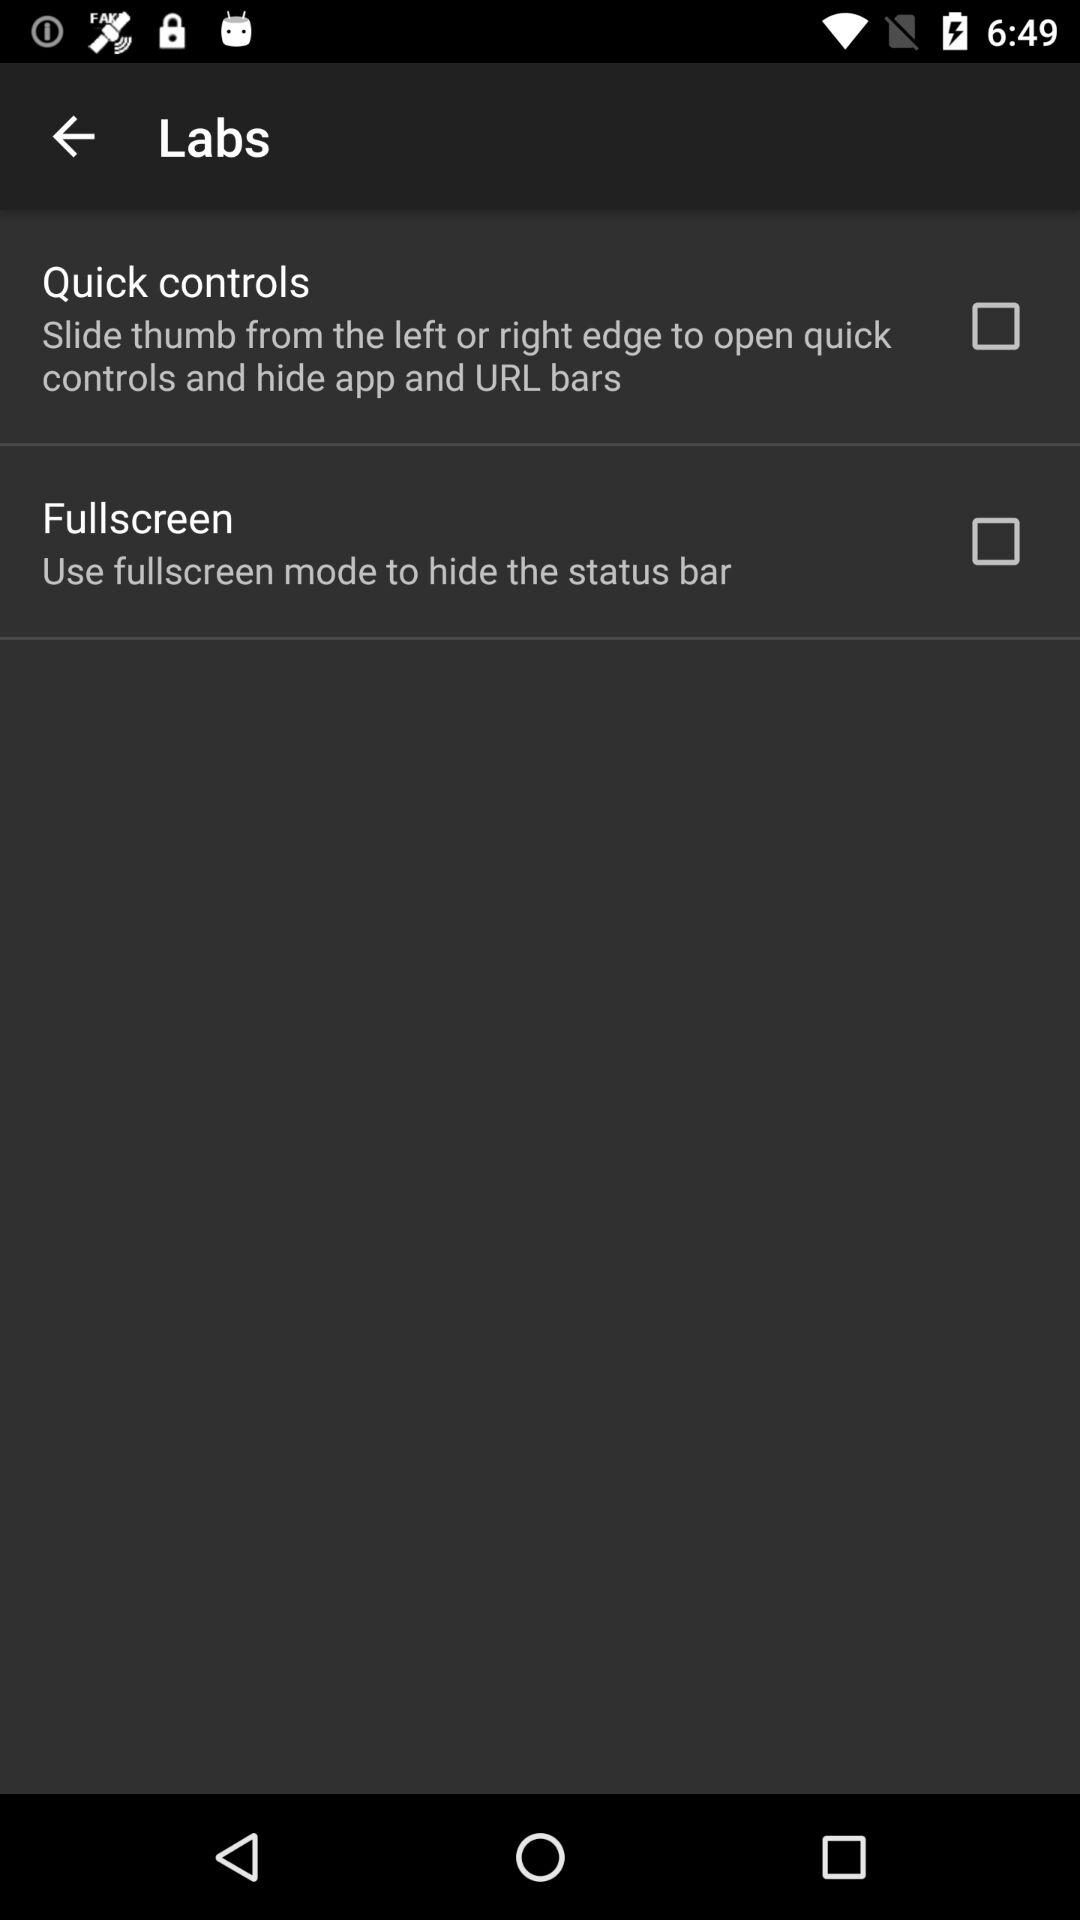What is the status of fullscreen? The status is off. 